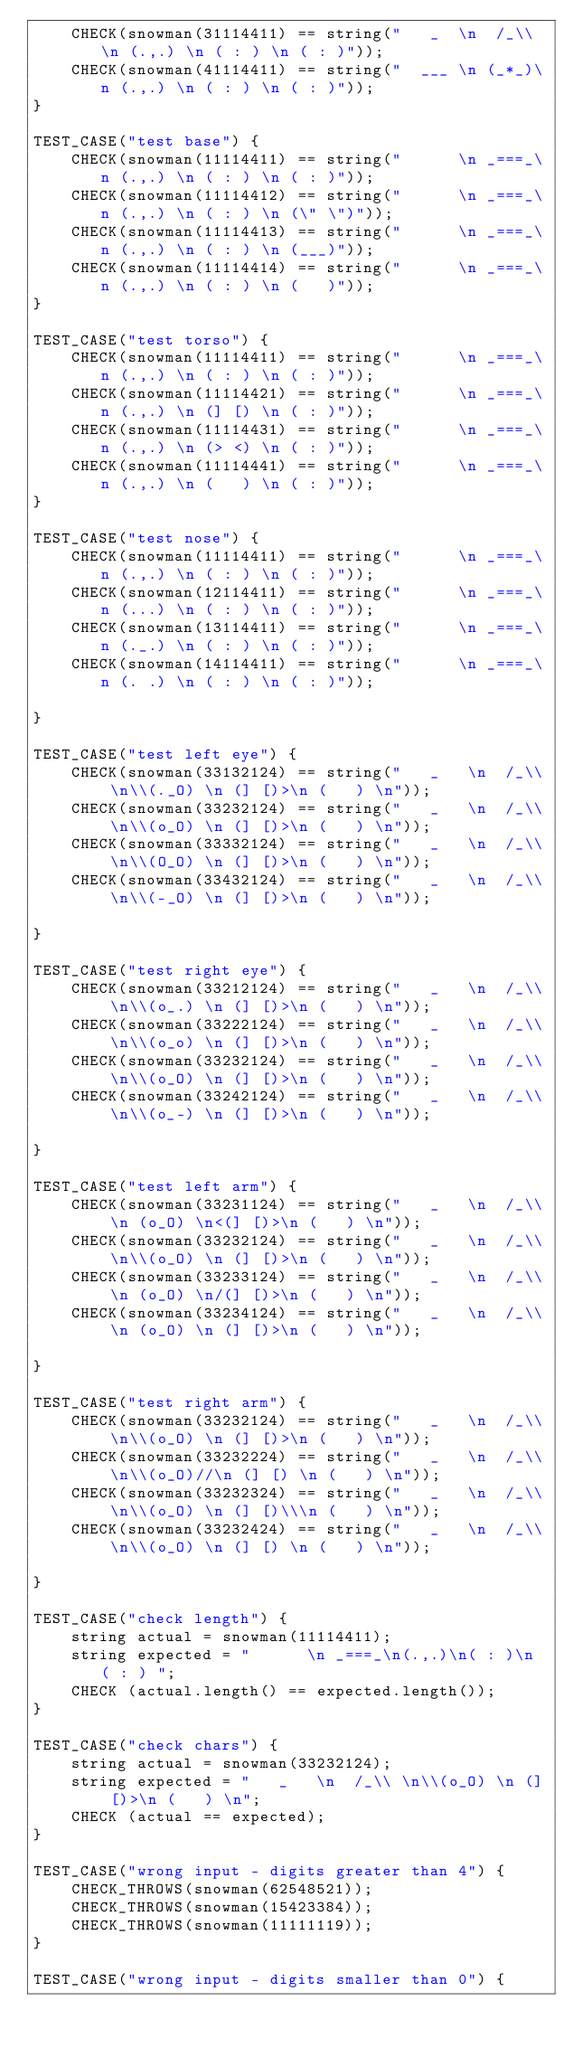Convert code to text. <code><loc_0><loc_0><loc_500><loc_500><_C++_>    CHECK(snowman(31114411) == string("   _  \n  /_\\ \n (.,.) \n ( : ) \n ( : )"));
    CHECK(snowman(41114411) == string("  ___ \n (_*_)\n (.,.) \n ( : ) \n ( : )"));
}

TEST_CASE("test base") {
    CHECK(snowman(11114411) == string("      \n _===_\n (.,.) \n ( : ) \n ( : )"));
    CHECK(snowman(11114412) == string("      \n _===_\n (.,.) \n ( : ) \n (\" \")"));
    CHECK(snowman(11114413) == string("      \n _===_\n (.,.) \n ( : ) \n (___)"));
    CHECK(snowman(11114414) == string("      \n _===_\n (.,.) \n ( : ) \n (   )"));
}

TEST_CASE("test torso") {
    CHECK(snowman(11114411) == string("      \n _===_\n (.,.) \n ( : ) \n ( : )"));
    CHECK(snowman(11114421) == string("      \n _===_\n (.,.) \n (] [) \n ( : )"));
    CHECK(snowman(11114431) == string("      \n _===_\n (.,.) \n (> <) \n ( : )"));
    CHECK(snowman(11114441) == string("      \n _===_\n (.,.) \n (   ) \n ( : )"));
}

TEST_CASE("test nose") {
    CHECK(snowman(11114411) == string("      \n _===_\n (.,.) \n ( : ) \n ( : )"));
    CHECK(snowman(12114411) == string("      \n _===_\n (...) \n ( : ) \n ( : )"));
    CHECK(snowman(13114411) == string("      \n _===_\n (._.) \n ( : ) \n ( : )"));
    CHECK(snowman(14114411) == string("      \n _===_\n (. .) \n ( : ) \n ( : )"));

}

TEST_CASE("test left eye") {
    CHECK(snowman(33132124) == string("   _   \n  /_\\ \n\\(._O) \n (] [)>\n (   ) \n"));
    CHECK(snowman(33232124) == string("   _   \n  /_\\ \n\\(o_O) \n (] [)>\n (   ) \n"));
    CHECK(snowman(33332124) == string("   _   \n  /_\\ \n\\(O_O) \n (] [)>\n (   ) \n"));
    CHECK(snowman(33432124) == string("   _   \n  /_\\ \n\\(-_O) \n (] [)>\n (   ) \n"));

}

TEST_CASE("test right eye") {
    CHECK(snowman(33212124) == string("   _   \n  /_\\ \n\\(o_.) \n (] [)>\n (   ) \n"));
    CHECK(snowman(33222124) == string("   _   \n  /_\\ \n\\(o_o) \n (] [)>\n (   ) \n"));
    CHECK(snowman(33232124) == string("   _   \n  /_\\ \n\\(o_O) \n (] [)>\n (   ) \n"));
    CHECK(snowman(33242124) == string("   _   \n  /_\\ \n\\(o_-) \n (] [)>\n (   ) \n"));

}

TEST_CASE("test left arm") {
    CHECK(snowman(33231124) == string("   _   \n  /_\\ \n (o_O) \n<(] [)>\n (   ) \n"));
    CHECK(snowman(33232124) == string("   _   \n  /_\\ \n\\(o_O) \n (] [)>\n (   ) \n"));
    CHECK(snowman(33233124) == string("   _   \n  /_\\ \n (o_O) \n/(] [)>\n (   ) \n"));
    CHECK(snowman(33234124) == string("   _   \n  /_\\ \n (o_O) \n (] [)>\n (   ) \n"));

}

TEST_CASE("test right arm") {
    CHECK(snowman(33232124) == string("   _   \n  /_\\ \n\\(o_O) \n (] [)>\n (   ) \n"));
    CHECK(snowman(33232224) == string("   _   \n  /_\\ \n\\(o_O)//\n (] [) \n (   ) \n"));
    CHECK(snowman(33232324) == string("   _   \n  /_\\ \n\\(o_O) \n (] [)\\\n (   ) \n"));
    CHECK(snowman(33232424) == string("   _   \n  /_\\ \n\\(o_O) \n (] [) \n (   ) \n"));

}

TEST_CASE("check length") {
    string actual = snowman(11114411);
    string expected = "      \n _===_\n(.,.)\n( : )\n ( : ) ";
    CHECK (actual.length() == expected.length());
}

TEST_CASE("check chars") {
    string actual = snowman(33232124);
    string expected = "   _   \n  /_\\ \n\\(o_O) \n (] [)>\n (   ) \n";
    CHECK (actual == expected);
}

TEST_CASE("wrong input - digits greater than 4") {
    CHECK_THROWS(snowman(62548521));
    CHECK_THROWS(snowman(15423384));
    CHECK_THROWS(snowman(11111119));
}

TEST_CASE("wrong input - digits smaller than 0") {</code> 